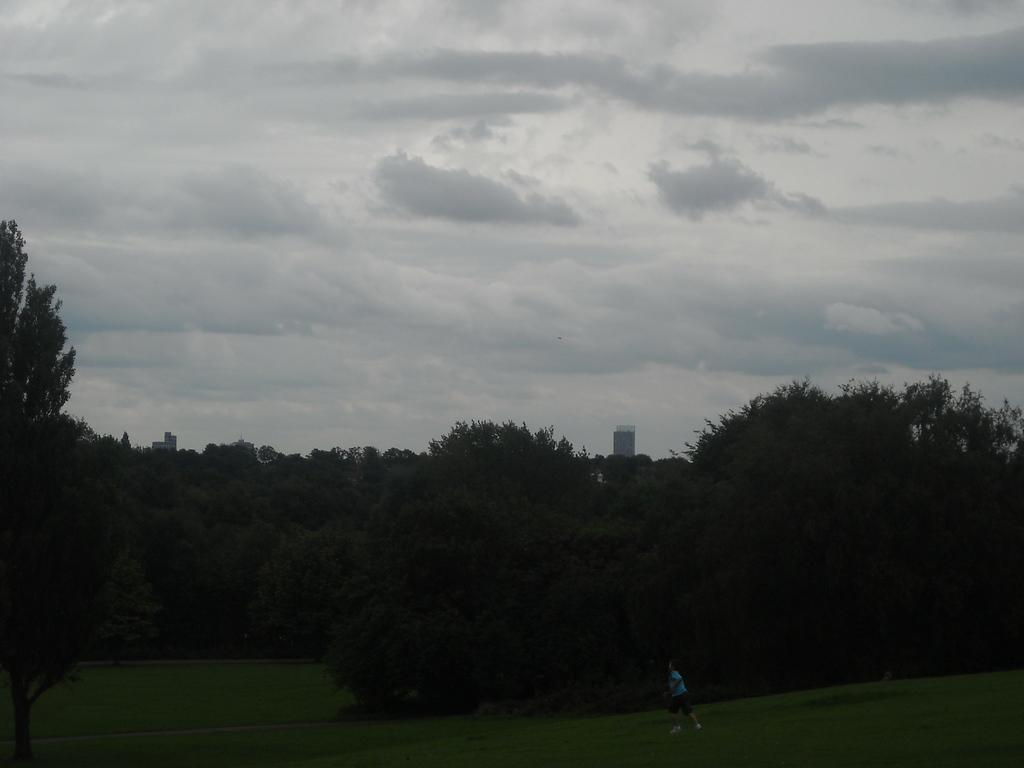What is happening in the image? There is a person in the image, and they are running. What surface is the person running on? The person is running on a grass path. What can be seen in the background of the image? There are trees visible in the background. How would you describe the sky in the image? The sky is cloudy in the image. What type of pan is being used to cook food in the image? There is no pan or cooking activity present in the image. What color is the paint on the trees in the image? The image does not show any paint on the trees; it only shows the natural color of the trees. 